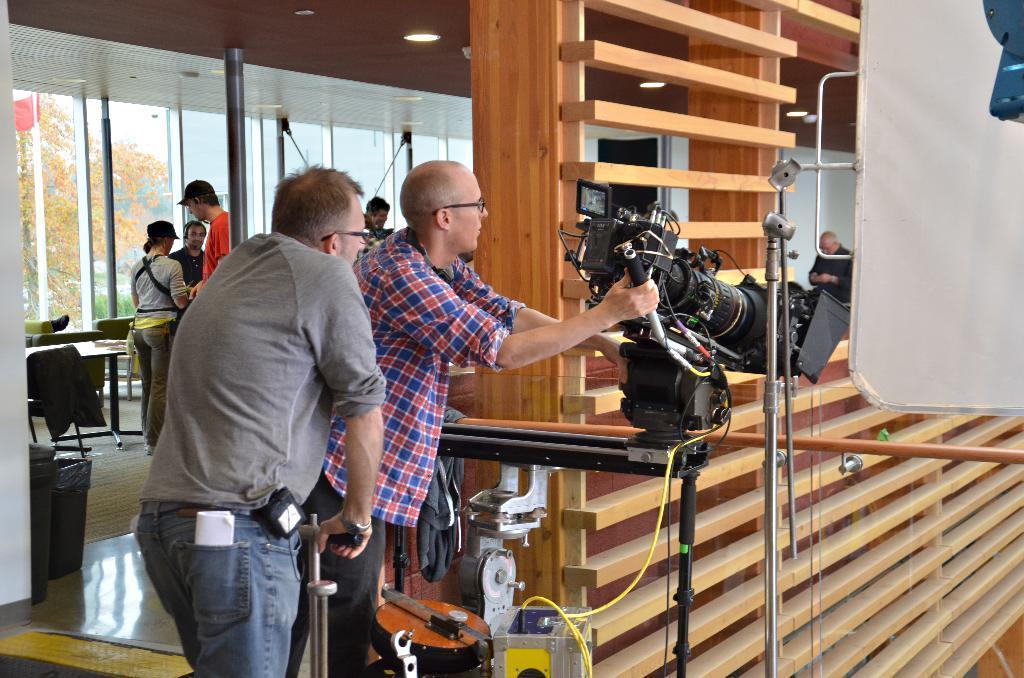Could you give a brief overview of what you see in this image? In this picture we can see some persons are standing on the floor. There are chairs and a table. Here we can see a man who is holding a camera. This is glass and there are some trees. 